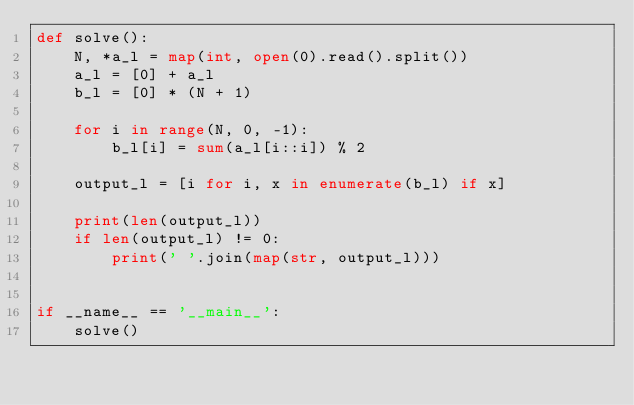<code> <loc_0><loc_0><loc_500><loc_500><_Python_>def solve():
    N, *a_l = map(int, open(0).read().split())
    a_l = [0] + a_l
    b_l = [0] * (N + 1)

    for i in range(N, 0, -1):
        b_l[i] = sum(a_l[i::i]) % 2
    
    output_l = [i for i, x in enumerate(b_l) if x]

    print(len(output_l))
    if len(output_l) != 0:
        print(' '.join(map(str, output_l)))


if __name__ == '__main__':
    solve()</code> 